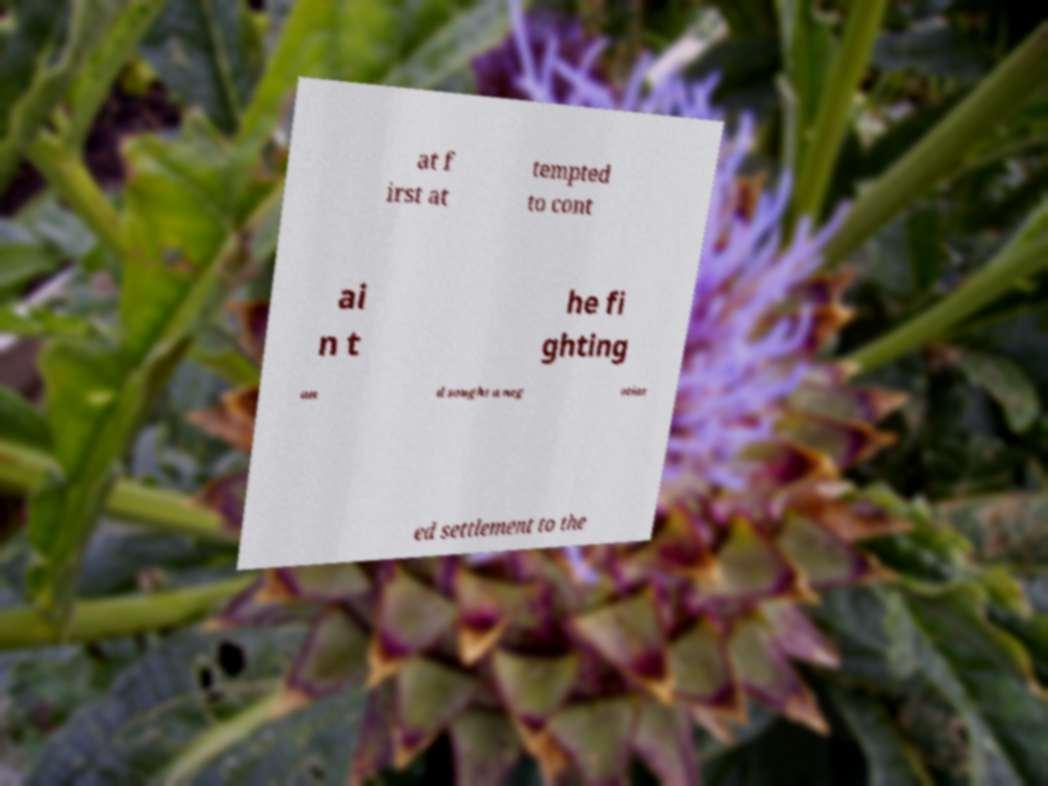Could you assist in decoding the text presented in this image and type it out clearly? at f irst at tempted to cont ai n t he fi ghting an d sought a neg otiat ed settlement to the 